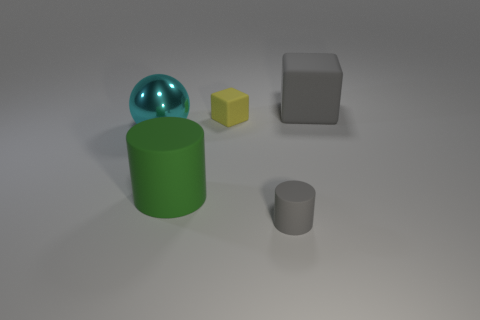There is a yellow object that is the same size as the gray rubber cylinder; what shape is it?
Your response must be concise. Cube. There is a block right of the rubber object that is in front of the big green rubber object; are there any tiny gray cylinders behind it?
Your response must be concise. No. Are there any yellow rubber blocks that have the same size as the metal object?
Provide a succinct answer. No. There is a gray rubber object that is in front of the big ball; what size is it?
Provide a short and direct response. Small. There is a large matte object that is to the right of the small matte thing that is behind the cyan metal ball in front of the tiny yellow block; what is its color?
Ensure brevity in your answer.  Gray. There is a rubber object that is in front of the matte cylinder that is behind the small rubber cylinder; what color is it?
Your response must be concise. Gray. Is the number of tiny objects that are to the right of the yellow rubber object greater than the number of yellow rubber blocks that are in front of the green rubber cylinder?
Your answer should be compact. Yes. Is the material of the gray thing in front of the big cyan shiny thing the same as the large object left of the green matte cylinder?
Your response must be concise. No. Are there any tiny yellow objects left of the big rubber cylinder?
Your response must be concise. No. What number of green things are either matte blocks or tiny objects?
Offer a terse response. 0. 